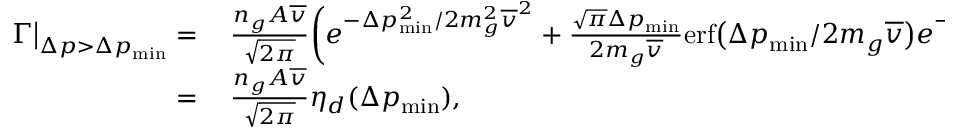Convert formula to latex. <formula><loc_0><loc_0><loc_500><loc_500>\begin{array} { r l } { \Gamma \Big | _ { \Delta p > \Delta p _ { \min } } = } & \, \frac { n _ { g } A \overline { v } } { \sqrt { 2 \pi } } \Big ( e ^ { - \Delta p _ { \min } ^ { 2 } / 2 m _ { g } ^ { 2 } \overline { v } ^ { 2 } } + \frac { \sqrt { \pi } \Delta p _ { \min } } { 2 m _ { g } \overline { v } } e r f \Big ( \Delta p _ { \min } / 2 m _ { g } \overline { v } \Big ) e ^ { - \Delta p _ { \min } ^ { 2 } \Big / 4 m _ { g } ^ { 2 } \overline { v } ^ { 2 } } \Big ) . } \\ { = } & \, \frac { n _ { g } A \overline { v } } { \sqrt { 2 \pi } } \eta _ { d } ( \Delta p _ { \min } ) , } \end{array}</formula> 